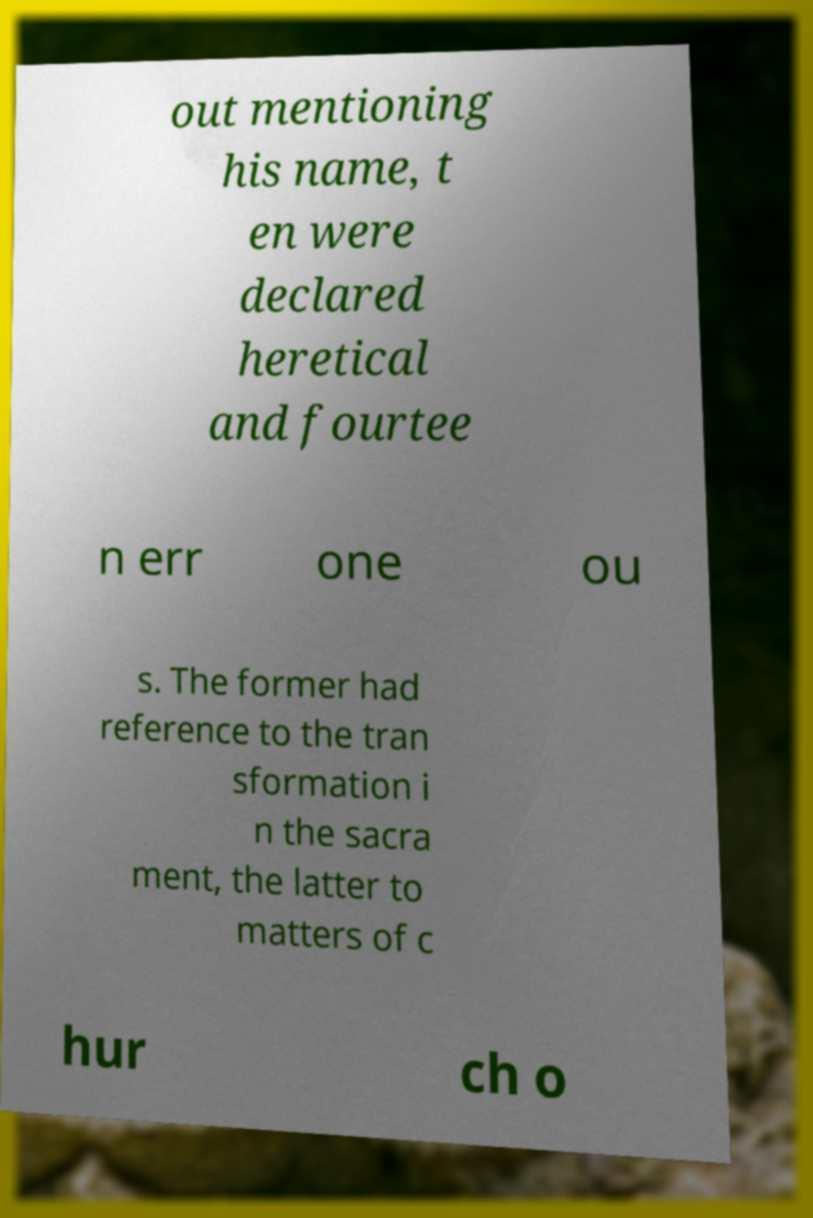Could you extract and type out the text from this image? out mentioning his name, t en were declared heretical and fourtee n err one ou s. The former had reference to the tran sformation i n the sacra ment, the latter to matters of c hur ch o 